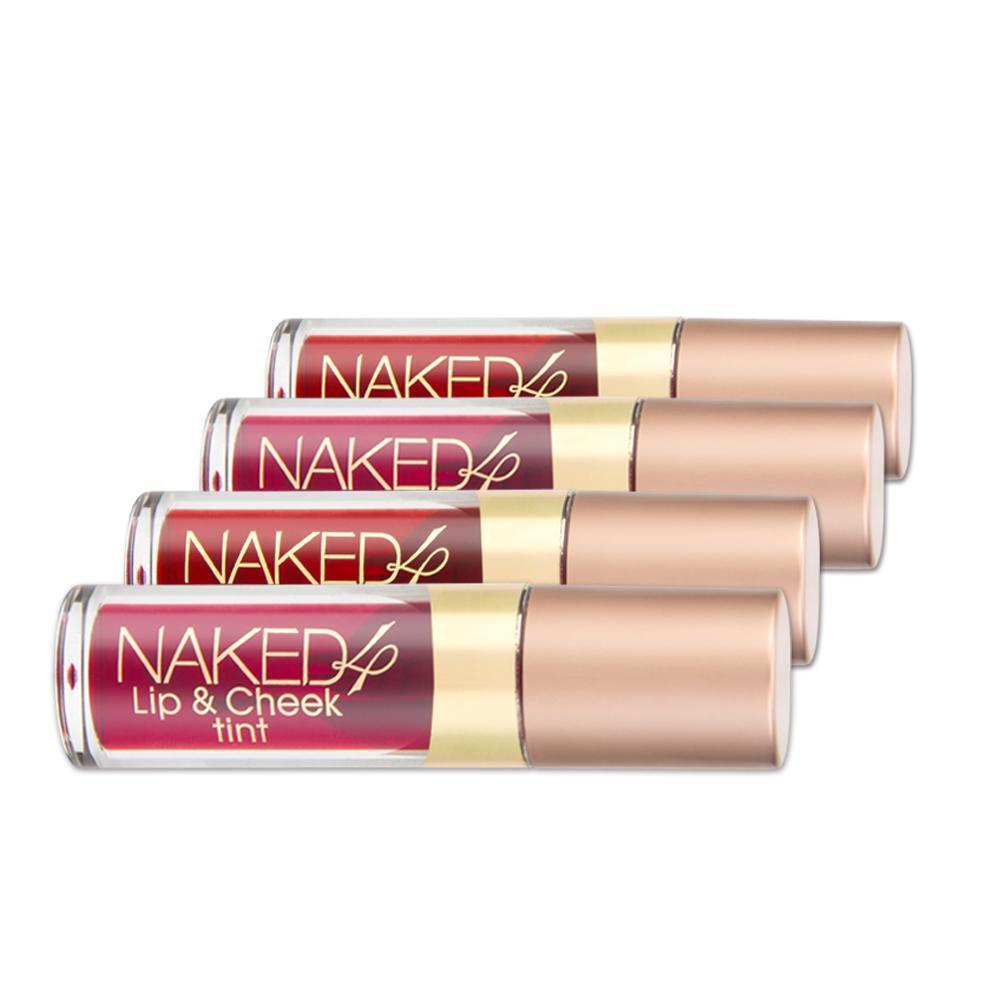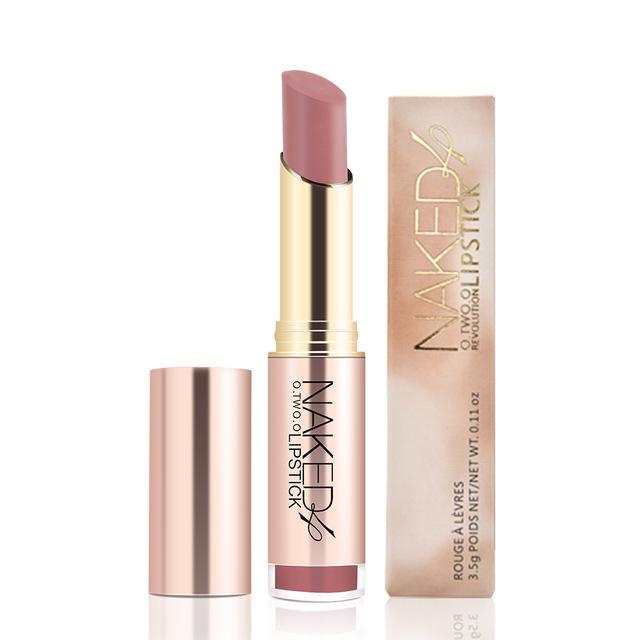The first image is the image on the left, the second image is the image on the right. Considering the images on both sides, is "All of the products are exactly vertical." valid? Answer yes or no. No. The first image is the image on the left, the second image is the image on the right. Evaluate the accuracy of this statement regarding the images: "Fewer than four lip products are displayed.". Is it true? Answer yes or no. No. 